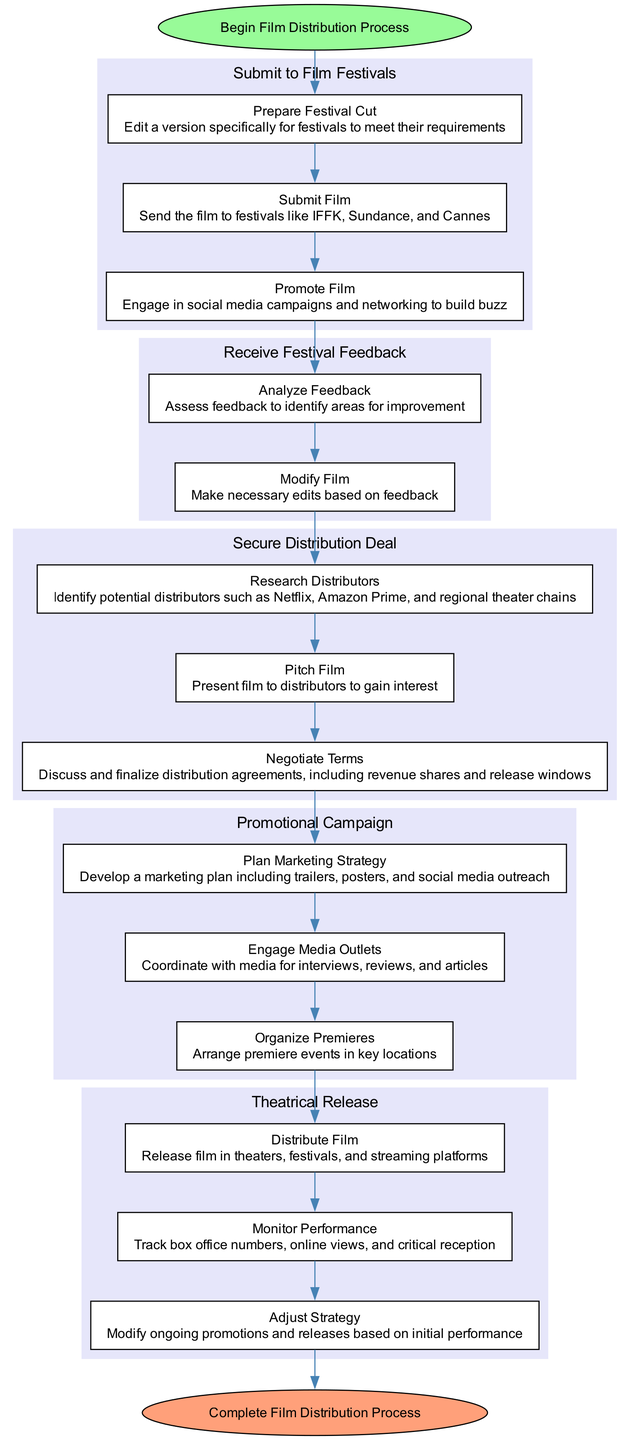What is the first action in the film distribution process? The first action is found in the "Submit to Film Festivals" node, specifically the first action listed under it is "Prepare Festival Cut".
Answer: Prepare Festival Cut How many nodes are present in the diagram? The diagram contains five main nodes that represent different stages in the film distribution process: Submit to Film Festivals, Receive Festival Feedback, Secure Distribution Deal, Promotional Campaign, and Theatrical Release.
Answer: Five What is the last action before the theatrical release? By following the sequence of actions, the last action before moving to the Theatrical Release is "Organize Premieres" from the Promotional Campaign node.
Answer: Organize Premieres Which node involves negotiating terms? The node that includes negotiating terms is "Secure Distribution Deal", and specifically, the action is "Negotiate Terms".
Answer: Secure Distribution Deal How many actions are there in total listed under the "Promotional Campaign" node? By scanning the "Promotional Campaign" node, we see that it consists of three actions: Plan Marketing Strategy, Engage Media Outlets, and Organize Premieres.
Answer: Three What action follows "Analyze Feedback"? In the "Receive Festival Feedback" node, after "Analyze Feedback" comes the action "Modify Film".
Answer: Modify Film Which two nodes are connected directly by an edge? "Receive Festival Feedback" and "Secure Distribution Deal" are directly connected by an edge, indicating a transition from one node to the next as part of the overall process.
Answer: Receive Festival Feedback and Secure Distribution Deal What is the ultimate goal after completing the process? The ultimate goal after all actions have been completed in the diagram is indicated by the end node which states "Complete Film Distribution Process".
Answer: Complete Film Distribution Process How many actions are there in the "Secure Distribution Deal" node? The "Secure Distribution Deal" node contains three actions: Research Distributors, Pitch Film, and Negotiate Terms.
Answer: Three What type of feedback is assessed after film festivals? The type of feedback assessed is "Festival Feedback", which is specifically addressed in the "Receive Festival Feedback" node.
Answer: Festival Feedback 